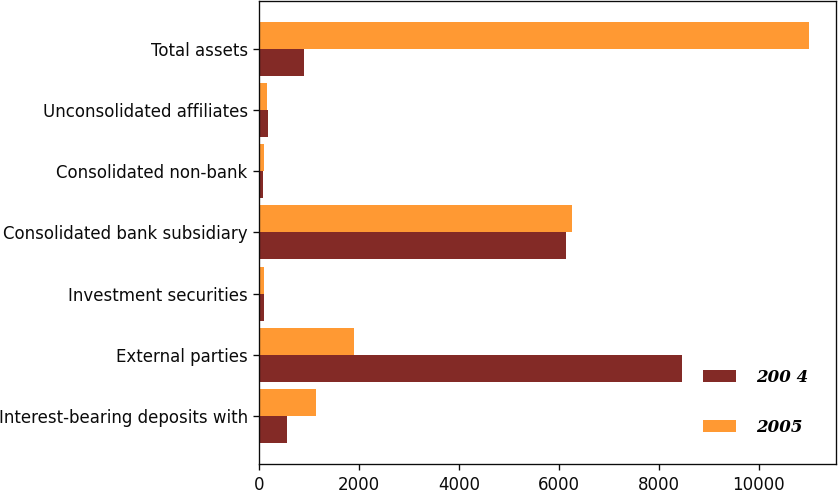Convert chart to OTSL. <chart><loc_0><loc_0><loc_500><loc_500><stacked_bar_chart><ecel><fcel>Interest-bearing deposits with<fcel>External parties<fcel>Investment securities<fcel>Consolidated bank subsidiary<fcel>Consolidated non-bank<fcel>Unconsolidated affiliates<fcel>Total assets<nl><fcel>200 4<fcel>550<fcel>8464<fcel>91<fcel>6139<fcel>71<fcel>164<fcel>898<nl><fcel>2005<fcel>1130<fcel>1901<fcel>101<fcel>6262<fcel>88<fcel>158<fcel>11004<nl></chart> 